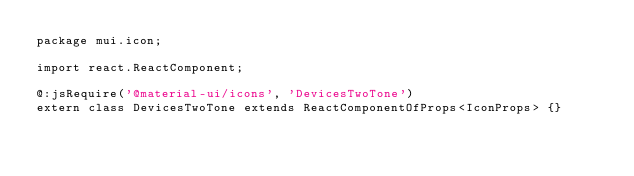<code> <loc_0><loc_0><loc_500><loc_500><_Haxe_>package mui.icon;

import react.ReactComponent;

@:jsRequire('@material-ui/icons', 'DevicesTwoTone')
extern class DevicesTwoTone extends ReactComponentOfProps<IconProps> {}
</code> 